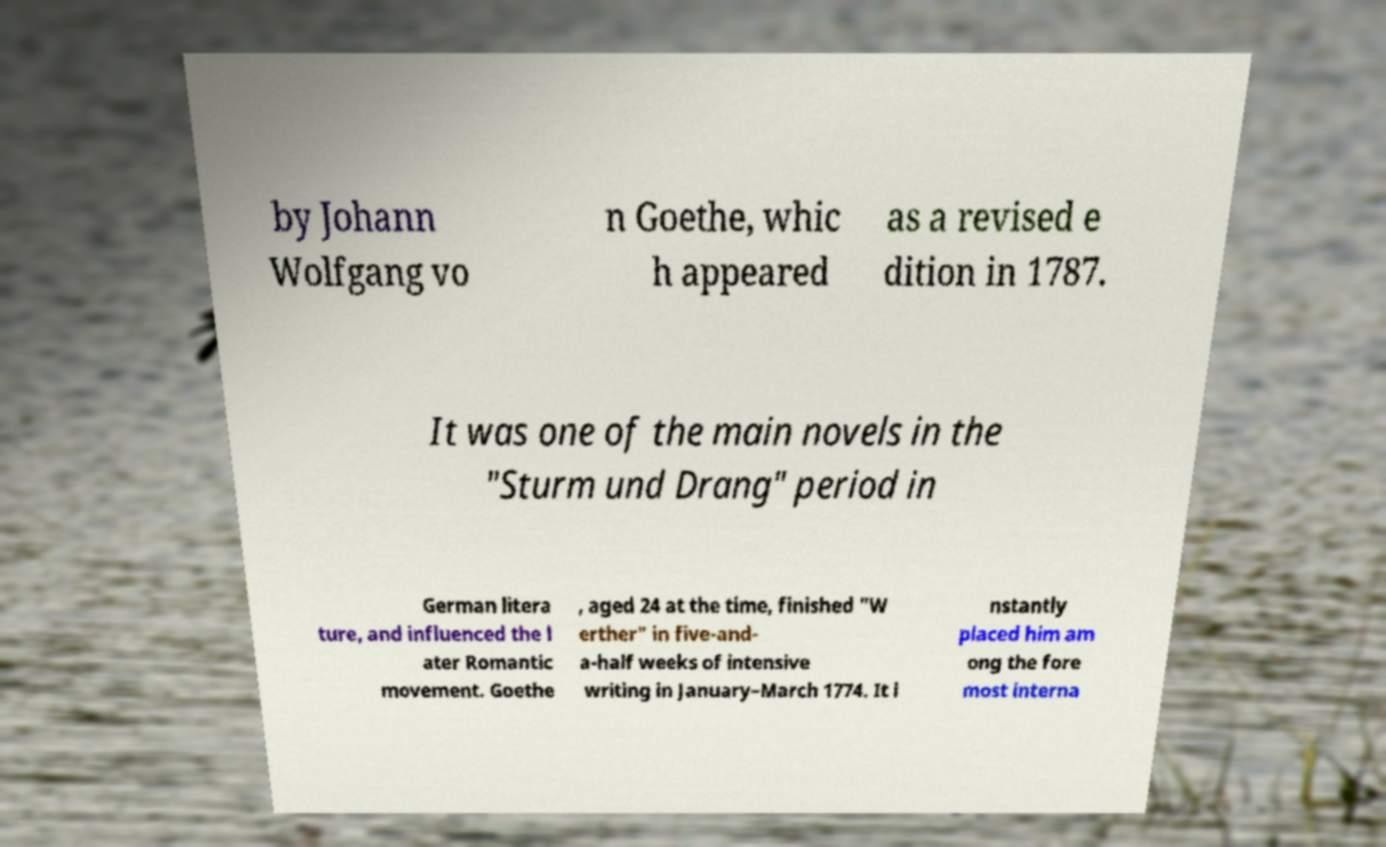Can you read and provide the text displayed in the image?This photo seems to have some interesting text. Can you extract and type it out for me? by Johann Wolfgang vo n Goethe, whic h appeared as a revised e dition in 1787. It was one of the main novels in the "Sturm und Drang" period in German litera ture, and influenced the l ater Romantic movement. Goethe , aged 24 at the time, finished "W erther" in five-and- a-half weeks of intensive writing in January–March 1774. It i nstantly placed him am ong the fore most interna 